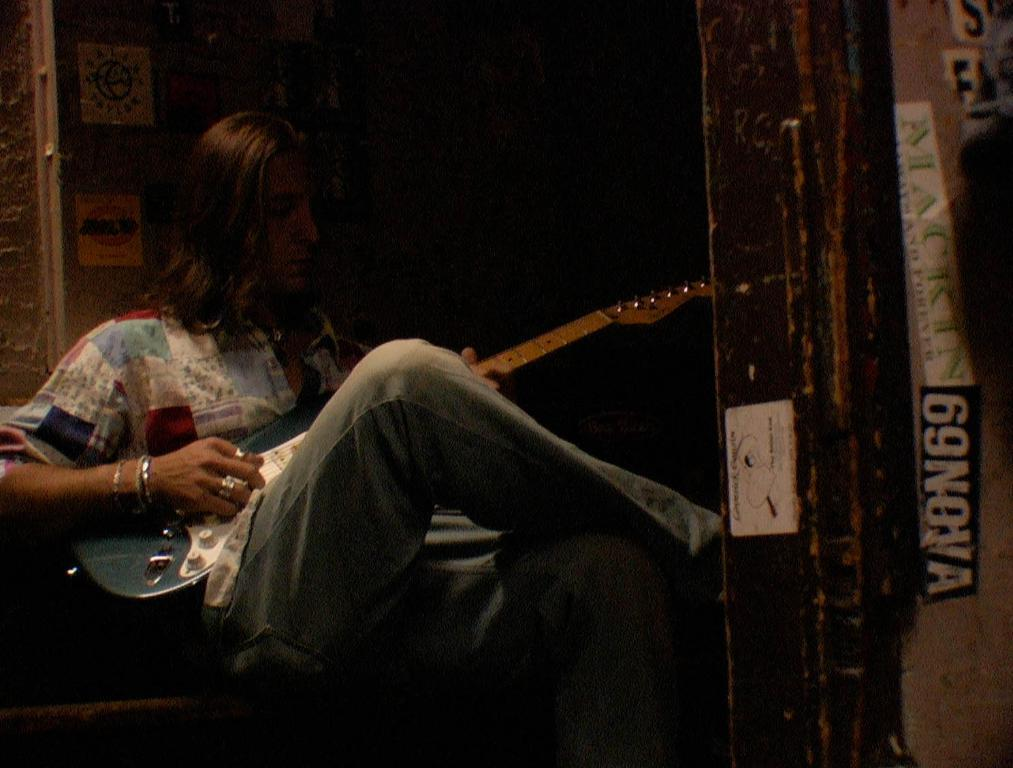<image>
Create a compact narrative representing the image presented. a man playing a guitar with a sticker that says 63NOVA on the wal 